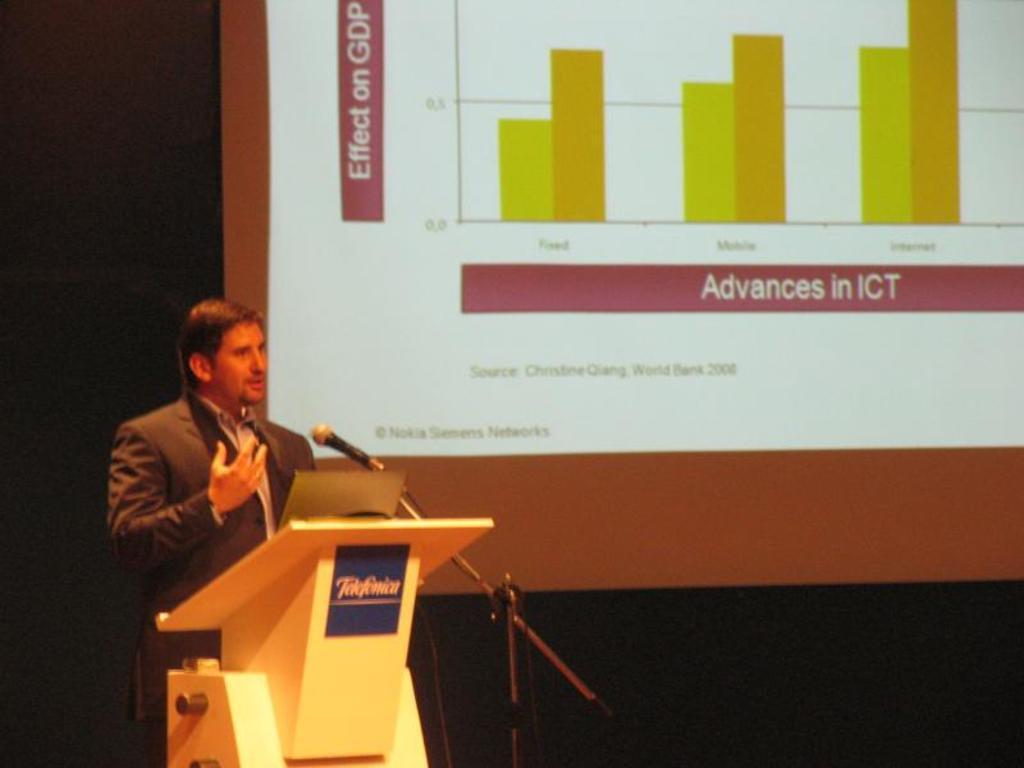Please provide a concise description of this image. Here in this picture on the left side we can see a person wearing a suit, standing over a place and speaking something in the microphone present in front of him and we can also see a speech desk present in front of him with a laptop on it and behind him we can see a projector screen with something projected on it. 